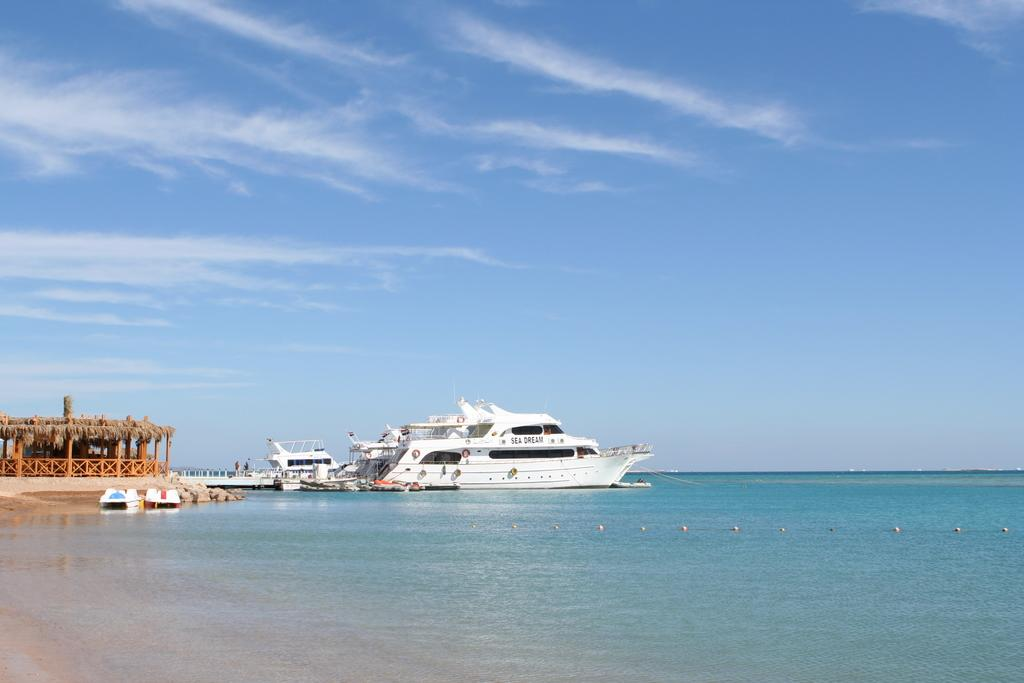What can be seen at the seashore in the image? There are ships at the seashore in the image. What type of temporary shelter is present in the image? There is a tent house in the image. What is the purpose of the fence in the image? The fence in the image serves as a boundary or barrier in the image. What is visible under the water in the image? Sea beds are visible in the image. What structure connects two points in the image? There is a bridge in the image. What are the ropes used for in the image? The ropes are present in the image, but their specific purpose is not clear. What is visible in the sky in the image? There are clouds in the sky in the image. What type of pleasure can be seen enjoying the sheet in the image? There is no pleasure or sheet present in the image. What type of crown is visible on the head of the person in the image? There is no person or crown present in the image. 